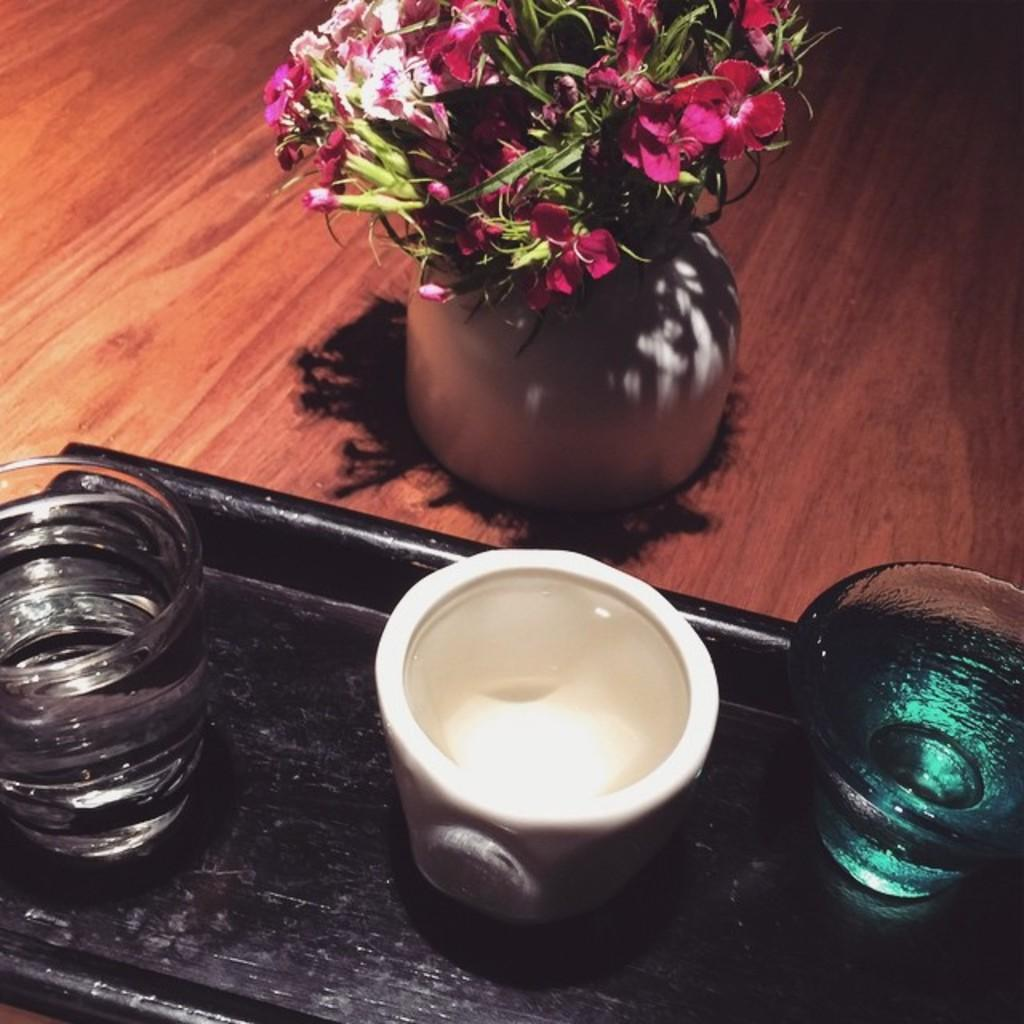What objects are on the black tray in the image? There are bowls on a black tray in the image. What else can be seen in the image besides the bowls on the tray? There is a flower vase in the image. Where is the flower vase located? The flower vase is on a wooden surface. What type of boat is featured in the image? There is no boat present in the image. 